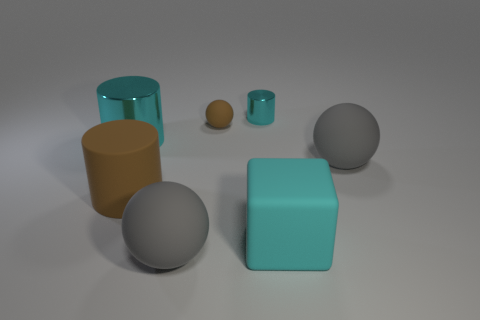What is the material of the large gray sphere on the right side of the cyan shiny cylinder that is on the right side of the big brown rubber cylinder?
Ensure brevity in your answer.  Rubber. Is there a big cylinder of the same color as the small cylinder?
Make the answer very short. Yes. There is a cyan thing that is made of the same material as the small brown object; what size is it?
Your answer should be compact. Large. Is there anything else that is the same color as the large cube?
Give a very brief answer. Yes. What is the color of the metal cylinder that is to the right of the large brown matte object?
Provide a short and direct response. Cyan. Is there a big brown cylinder to the left of the cyan metallic cylinder that is in front of the cyan shiny cylinder to the right of the rubber cylinder?
Your answer should be compact. No. Is the number of large gray matte spheres that are behind the small cyan shiny thing greater than the number of brown rubber objects?
Ensure brevity in your answer.  No. Do the small cyan metallic object that is behind the rubber cube and the large brown matte object have the same shape?
Offer a terse response. Yes. How many things are either yellow cubes or gray rubber things that are right of the tiny rubber thing?
Provide a short and direct response. 1. What is the size of the sphere that is behind the large block and in front of the large cyan metal cylinder?
Offer a very short reply. Large. 